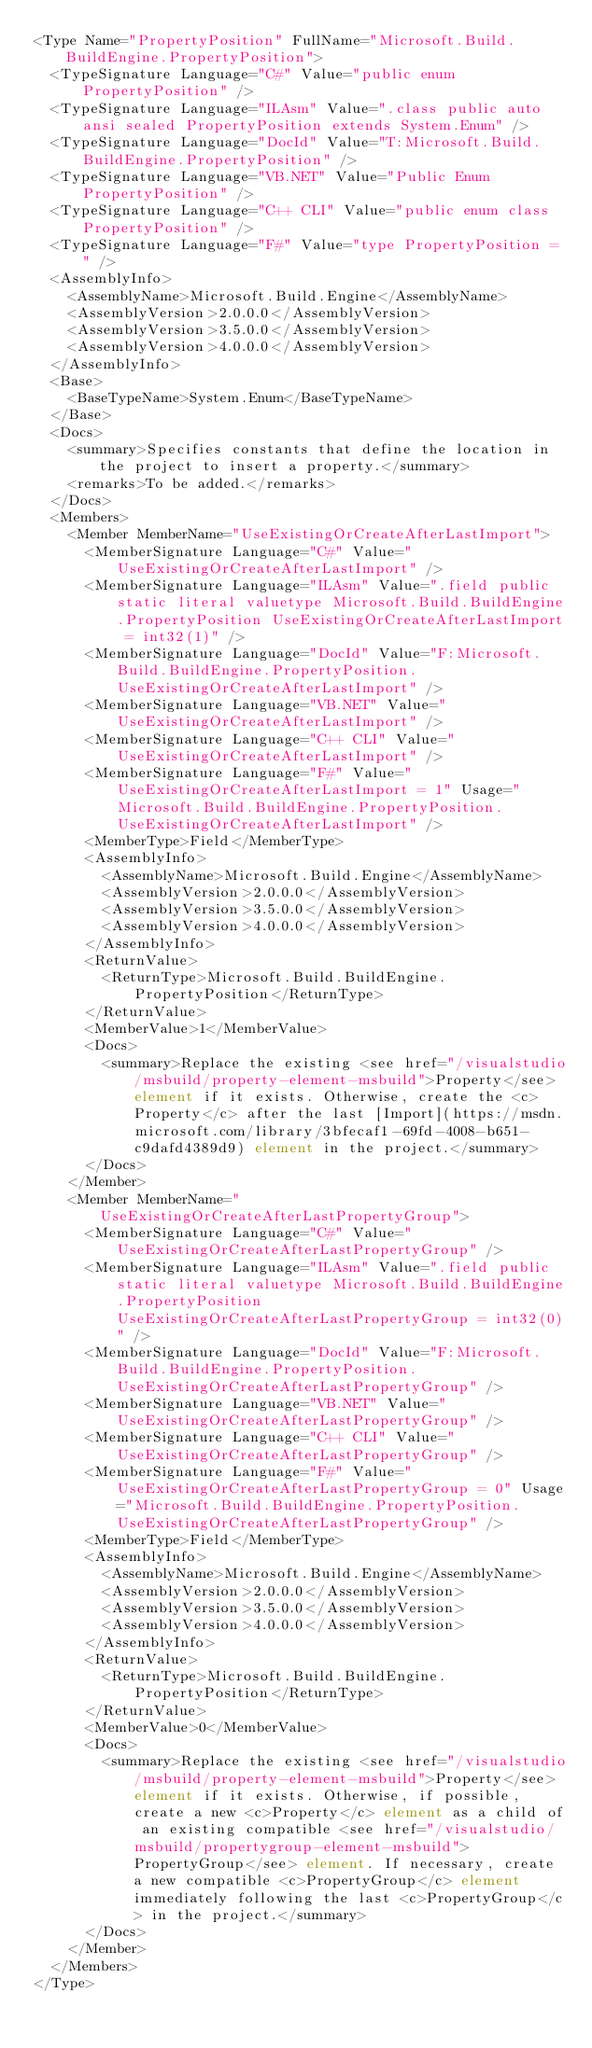Convert code to text. <code><loc_0><loc_0><loc_500><loc_500><_XML_><Type Name="PropertyPosition" FullName="Microsoft.Build.BuildEngine.PropertyPosition">
  <TypeSignature Language="C#" Value="public enum PropertyPosition" />
  <TypeSignature Language="ILAsm" Value=".class public auto ansi sealed PropertyPosition extends System.Enum" />
  <TypeSignature Language="DocId" Value="T:Microsoft.Build.BuildEngine.PropertyPosition" />
  <TypeSignature Language="VB.NET" Value="Public Enum PropertyPosition" />
  <TypeSignature Language="C++ CLI" Value="public enum class PropertyPosition" />
  <TypeSignature Language="F#" Value="type PropertyPosition = " />
  <AssemblyInfo>
    <AssemblyName>Microsoft.Build.Engine</AssemblyName>
    <AssemblyVersion>2.0.0.0</AssemblyVersion>
    <AssemblyVersion>3.5.0.0</AssemblyVersion>
    <AssemblyVersion>4.0.0.0</AssemblyVersion>
  </AssemblyInfo>
  <Base>
    <BaseTypeName>System.Enum</BaseTypeName>
  </Base>
  <Docs>
    <summary>Specifies constants that define the location in the project to insert a property.</summary>
    <remarks>To be added.</remarks>
  </Docs>
  <Members>
    <Member MemberName="UseExistingOrCreateAfterLastImport">
      <MemberSignature Language="C#" Value="UseExistingOrCreateAfterLastImport" />
      <MemberSignature Language="ILAsm" Value=".field public static literal valuetype Microsoft.Build.BuildEngine.PropertyPosition UseExistingOrCreateAfterLastImport = int32(1)" />
      <MemberSignature Language="DocId" Value="F:Microsoft.Build.BuildEngine.PropertyPosition.UseExistingOrCreateAfterLastImport" />
      <MemberSignature Language="VB.NET" Value="UseExistingOrCreateAfterLastImport" />
      <MemberSignature Language="C++ CLI" Value="UseExistingOrCreateAfterLastImport" />
      <MemberSignature Language="F#" Value="UseExistingOrCreateAfterLastImport = 1" Usage="Microsoft.Build.BuildEngine.PropertyPosition.UseExistingOrCreateAfterLastImport" />
      <MemberType>Field</MemberType>
      <AssemblyInfo>
        <AssemblyName>Microsoft.Build.Engine</AssemblyName>
        <AssemblyVersion>2.0.0.0</AssemblyVersion>
        <AssemblyVersion>3.5.0.0</AssemblyVersion>
        <AssemblyVersion>4.0.0.0</AssemblyVersion>
      </AssemblyInfo>
      <ReturnValue>
        <ReturnType>Microsoft.Build.BuildEngine.PropertyPosition</ReturnType>
      </ReturnValue>
      <MemberValue>1</MemberValue>
      <Docs>
        <summary>Replace the existing <see href="/visualstudio/msbuild/property-element-msbuild">Property</see> element if it exists. Otherwise, create the <c>Property</c> after the last [Import](https://msdn.microsoft.com/library/3bfecaf1-69fd-4008-b651-c9dafd4389d9) element in the project.</summary>
      </Docs>
    </Member>
    <Member MemberName="UseExistingOrCreateAfterLastPropertyGroup">
      <MemberSignature Language="C#" Value="UseExistingOrCreateAfterLastPropertyGroup" />
      <MemberSignature Language="ILAsm" Value=".field public static literal valuetype Microsoft.Build.BuildEngine.PropertyPosition UseExistingOrCreateAfterLastPropertyGroup = int32(0)" />
      <MemberSignature Language="DocId" Value="F:Microsoft.Build.BuildEngine.PropertyPosition.UseExistingOrCreateAfterLastPropertyGroup" />
      <MemberSignature Language="VB.NET" Value="UseExistingOrCreateAfterLastPropertyGroup" />
      <MemberSignature Language="C++ CLI" Value="UseExistingOrCreateAfterLastPropertyGroup" />
      <MemberSignature Language="F#" Value="UseExistingOrCreateAfterLastPropertyGroup = 0" Usage="Microsoft.Build.BuildEngine.PropertyPosition.UseExistingOrCreateAfterLastPropertyGroup" />
      <MemberType>Field</MemberType>
      <AssemblyInfo>
        <AssemblyName>Microsoft.Build.Engine</AssemblyName>
        <AssemblyVersion>2.0.0.0</AssemblyVersion>
        <AssemblyVersion>3.5.0.0</AssemblyVersion>
        <AssemblyVersion>4.0.0.0</AssemblyVersion>
      </AssemblyInfo>
      <ReturnValue>
        <ReturnType>Microsoft.Build.BuildEngine.PropertyPosition</ReturnType>
      </ReturnValue>
      <MemberValue>0</MemberValue>
      <Docs>
        <summary>Replace the existing <see href="/visualstudio/msbuild/property-element-msbuild">Property</see> element if it exists. Otherwise, if possible, create a new <c>Property</c> element as a child of an existing compatible <see href="/visualstudio/msbuild/propertygroup-element-msbuild">PropertyGroup</see> element. If necessary, create a new compatible <c>PropertyGroup</c> element immediately following the last <c>PropertyGroup</c> in the project.</summary>
      </Docs>
    </Member>
  </Members>
</Type>
</code> 